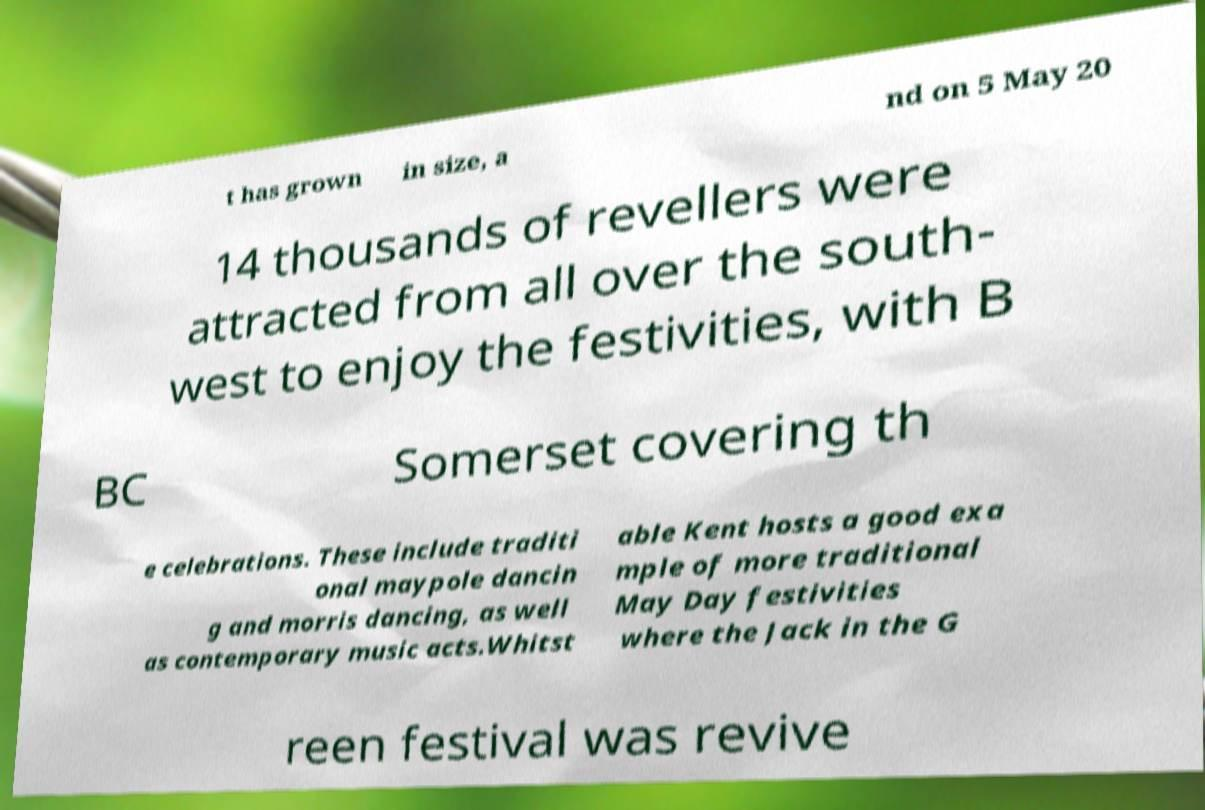There's text embedded in this image that I need extracted. Can you transcribe it verbatim? t has grown in size, a nd on 5 May 20 14 thousands of revellers were attracted from all over the south- west to enjoy the festivities, with B BC Somerset covering th e celebrations. These include traditi onal maypole dancin g and morris dancing, as well as contemporary music acts.Whitst able Kent hosts a good exa mple of more traditional May Day festivities where the Jack in the G reen festival was revive 